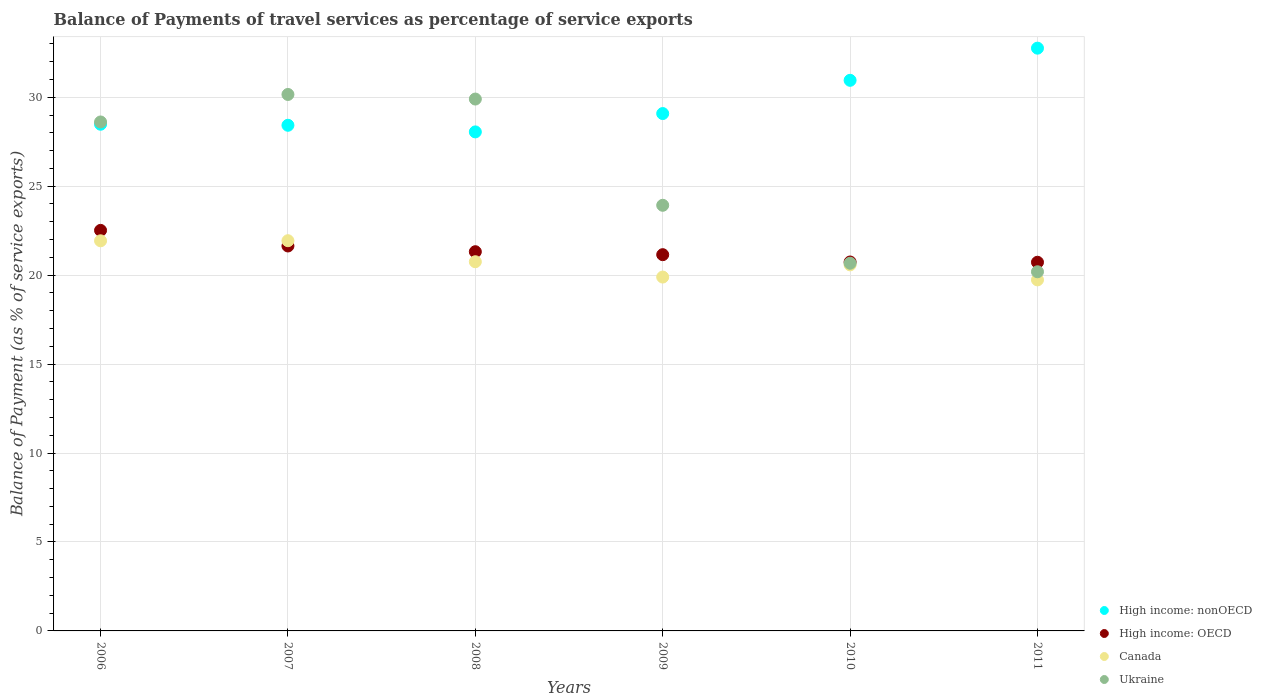How many different coloured dotlines are there?
Offer a very short reply. 4. Is the number of dotlines equal to the number of legend labels?
Provide a succinct answer. Yes. What is the balance of payments of travel services in High income: OECD in 2008?
Your response must be concise. 21.32. Across all years, what is the maximum balance of payments of travel services in Canada?
Provide a short and direct response. 21.94. Across all years, what is the minimum balance of payments of travel services in High income: nonOECD?
Your response must be concise. 28.05. In which year was the balance of payments of travel services in Ukraine maximum?
Ensure brevity in your answer.  2007. In which year was the balance of payments of travel services in Canada minimum?
Ensure brevity in your answer.  2011. What is the total balance of payments of travel services in Canada in the graph?
Offer a very short reply. 124.82. What is the difference between the balance of payments of travel services in Ukraine in 2008 and that in 2009?
Give a very brief answer. 5.97. What is the difference between the balance of payments of travel services in Ukraine in 2006 and the balance of payments of travel services in Canada in 2010?
Give a very brief answer. 8.03. What is the average balance of payments of travel services in Canada per year?
Ensure brevity in your answer.  20.8. In the year 2006, what is the difference between the balance of payments of travel services in Ukraine and balance of payments of travel services in Canada?
Your response must be concise. 6.68. What is the ratio of the balance of payments of travel services in High income: nonOECD in 2010 to that in 2011?
Provide a succinct answer. 0.94. Is the difference between the balance of payments of travel services in Ukraine in 2007 and 2009 greater than the difference between the balance of payments of travel services in Canada in 2007 and 2009?
Ensure brevity in your answer.  Yes. What is the difference between the highest and the second highest balance of payments of travel services in High income: nonOECD?
Your response must be concise. 1.81. What is the difference between the highest and the lowest balance of payments of travel services in High income: nonOECD?
Provide a succinct answer. 4.71. In how many years, is the balance of payments of travel services in High income: nonOECD greater than the average balance of payments of travel services in High income: nonOECD taken over all years?
Offer a terse response. 2. Is the sum of the balance of payments of travel services in High income: nonOECD in 2006 and 2010 greater than the maximum balance of payments of travel services in Canada across all years?
Your response must be concise. Yes. Is it the case that in every year, the sum of the balance of payments of travel services in Canada and balance of payments of travel services in Ukraine  is greater than the sum of balance of payments of travel services in High income: nonOECD and balance of payments of travel services in High income: OECD?
Provide a short and direct response. No. Is it the case that in every year, the sum of the balance of payments of travel services in High income: OECD and balance of payments of travel services in High income: nonOECD  is greater than the balance of payments of travel services in Canada?
Provide a succinct answer. Yes. Does the balance of payments of travel services in High income: nonOECD monotonically increase over the years?
Keep it short and to the point. No. Is the balance of payments of travel services in High income: OECD strictly greater than the balance of payments of travel services in Canada over the years?
Provide a short and direct response. No. What is the difference between two consecutive major ticks on the Y-axis?
Offer a terse response. 5. Are the values on the major ticks of Y-axis written in scientific E-notation?
Your response must be concise. No. Does the graph contain any zero values?
Keep it short and to the point. No. Does the graph contain grids?
Provide a succinct answer. Yes. How many legend labels are there?
Offer a very short reply. 4. How are the legend labels stacked?
Give a very brief answer. Vertical. What is the title of the graph?
Provide a succinct answer. Balance of Payments of travel services as percentage of service exports. What is the label or title of the Y-axis?
Your answer should be very brief. Balance of Payment (as % of service exports). What is the Balance of Payment (as % of service exports) of High income: nonOECD in 2006?
Your response must be concise. 28.48. What is the Balance of Payment (as % of service exports) in High income: OECD in 2006?
Ensure brevity in your answer.  22.52. What is the Balance of Payment (as % of service exports) in Canada in 2006?
Your response must be concise. 21.93. What is the Balance of Payment (as % of service exports) of Ukraine in 2006?
Ensure brevity in your answer.  28.61. What is the Balance of Payment (as % of service exports) in High income: nonOECD in 2007?
Ensure brevity in your answer.  28.42. What is the Balance of Payment (as % of service exports) in High income: OECD in 2007?
Offer a terse response. 21.64. What is the Balance of Payment (as % of service exports) of Canada in 2007?
Make the answer very short. 21.94. What is the Balance of Payment (as % of service exports) of Ukraine in 2007?
Keep it short and to the point. 30.16. What is the Balance of Payment (as % of service exports) in High income: nonOECD in 2008?
Give a very brief answer. 28.05. What is the Balance of Payment (as % of service exports) of High income: OECD in 2008?
Offer a terse response. 21.32. What is the Balance of Payment (as % of service exports) in Canada in 2008?
Make the answer very short. 20.75. What is the Balance of Payment (as % of service exports) of Ukraine in 2008?
Your response must be concise. 29.9. What is the Balance of Payment (as % of service exports) in High income: nonOECD in 2009?
Your answer should be very brief. 29.08. What is the Balance of Payment (as % of service exports) in High income: OECD in 2009?
Offer a terse response. 21.15. What is the Balance of Payment (as % of service exports) in Canada in 2009?
Provide a short and direct response. 19.89. What is the Balance of Payment (as % of service exports) in Ukraine in 2009?
Your answer should be compact. 23.93. What is the Balance of Payment (as % of service exports) in High income: nonOECD in 2010?
Provide a succinct answer. 30.95. What is the Balance of Payment (as % of service exports) in High income: OECD in 2010?
Offer a terse response. 20.74. What is the Balance of Payment (as % of service exports) in Canada in 2010?
Your answer should be compact. 20.58. What is the Balance of Payment (as % of service exports) of Ukraine in 2010?
Give a very brief answer. 20.67. What is the Balance of Payment (as % of service exports) of High income: nonOECD in 2011?
Your response must be concise. 32.76. What is the Balance of Payment (as % of service exports) in High income: OECD in 2011?
Ensure brevity in your answer.  20.72. What is the Balance of Payment (as % of service exports) in Canada in 2011?
Keep it short and to the point. 19.73. What is the Balance of Payment (as % of service exports) in Ukraine in 2011?
Offer a very short reply. 20.19. Across all years, what is the maximum Balance of Payment (as % of service exports) in High income: nonOECD?
Keep it short and to the point. 32.76. Across all years, what is the maximum Balance of Payment (as % of service exports) of High income: OECD?
Your answer should be very brief. 22.52. Across all years, what is the maximum Balance of Payment (as % of service exports) of Canada?
Provide a succinct answer. 21.94. Across all years, what is the maximum Balance of Payment (as % of service exports) of Ukraine?
Provide a short and direct response. 30.16. Across all years, what is the minimum Balance of Payment (as % of service exports) of High income: nonOECD?
Your response must be concise. 28.05. Across all years, what is the minimum Balance of Payment (as % of service exports) of High income: OECD?
Your answer should be very brief. 20.72. Across all years, what is the minimum Balance of Payment (as % of service exports) in Canada?
Offer a terse response. 19.73. Across all years, what is the minimum Balance of Payment (as % of service exports) of Ukraine?
Your response must be concise. 20.19. What is the total Balance of Payment (as % of service exports) of High income: nonOECD in the graph?
Provide a short and direct response. 177.75. What is the total Balance of Payment (as % of service exports) of High income: OECD in the graph?
Your response must be concise. 128.09. What is the total Balance of Payment (as % of service exports) in Canada in the graph?
Offer a terse response. 124.82. What is the total Balance of Payment (as % of service exports) of Ukraine in the graph?
Your response must be concise. 153.45. What is the difference between the Balance of Payment (as % of service exports) in High income: nonOECD in 2006 and that in 2007?
Offer a very short reply. 0.06. What is the difference between the Balance of Payment (as % of service exports) of High income: OECD in 2006 and that in 2007?
Provide a succinct answer. 0.88. What is the difference between the Balance of Payment (as % of service exports) in Canada in 2006 and that in 2007?
Provide a succinct answer. -0.01. What is the difference between the Balance of Payment (as % of service exports) in Ukraine in 2006 and that in 2007?
Give a very brief answer. -1.55. What is the difference between the Balance of Payment (as % of service exports) of High income: nonOECD in 2006 and that in 2008?
Provide a short and direct response. 0.43. What is the difference between the Balance of Payment (as % of service exports) of High income: OECD in 2006 and that in 2008?
Your answer should be very brief. 1.2. What is the difference between the Balance of Payment (as % of service exports) in Canada in 2006 and that in 2008?
Give a very brief answer. 1.18. What is the difference between the Balance of Payment (as % of service exports) in Ukraine in 2006 and that in 2008?
Offer a very short reply. -1.29. What is the difference between the Balance of Payment (as % of service exports) of High income: nonOECD in 2006 and that in 2009?
Your response must be concise. -0.6. What is the difference between the Balance of Payment (as % of service exports) in High income: OECD in 2006 and that in 2009?
Keep it short and to the point. 1.37. What is the difference between the Balance of Payment (as % of service exports) in Canada in 2006 and that in 2009?
Your answer should be very brief. 2.04. What is the difference between the Balance of Payment (as % of service exports) of Ukraine in 2006 and that in 2009?
Your answer should be very brief. 4.68. What is the difference between the Balance of Payment (as % of service exports) in High income: nonOECD in 2006 and that in 2010?
Your answer should be very brief. -2.47. What is the difference between the Balance of Payment (as % of service exports) of High income: OECD in 2006 and that in 2010?
Offer a terse response. 1.78. What is the difference between the Balance of Payment (as % of service exports) of Canada in 2006 and that in 2010?
Ensure brevity in your answer.  1.35. What is the difference between the Balance of Payment (as % of service exports) in Ukraine in 2006 and that in 2010?
Your answer should be compact. 7.94. What is the difference between the Balance of Payment (as % of service exports) of High income: nonOECD in 2006 and that in 2011?
Your answer should be compact. -4.28. What is the difference between the Balance of Payment (as % of service exports) of High income: OECD in 2006 and that in 2011?
Keep it short and to the point. 1.79. What is the difference between the Balance of Payment (as % of service exports) in Canada in 2006 and that in 2011?
Keep it short and to the point. 2.2. What is the difference between the Balance of Payment (as % of service exports) of Ukraine in 2006 and that in 2011?
Offer a very short reply. 8.42. What is the difference between the Balance of Payment (as % of service exports) of High income: nonOECD in 2007 and that in 2008?
Provide a short and direct response. 0.37. What is the difference between the Balance of Payment (as % of service exports) of High income: OECD in 2007 and that in 2008?
Your response must be concise. 0.32. What is the difference between the Balance of Payment (as % of service exports) of Canada in 2007 and that in 2008?
Offer a very short reply. 1.18. What is the difference between the Balance of Payment (as % of service exports) in Ukraine in 2007 and that in 2008?
Your answer should be very brief. 0.26. What is the difference between the Balance of Payment (as % of service exports) of High income: nonOECD in 2007 and that in 2009?
Your answer should be very brief. -0.66. What is the difference between the Balance of Payment (as % of service exports) of High income: OECD in 2007 and that in 2009?
Keep it short and to the point. 0.49. What is the difference between the Balance of Payment (as % of service exports) in Canada in 2007 and that in 2009?
Make the answer very short. 2.04. What is the difference between the Balance of Payment (as % of service exports) in Ukraine in 2007 and that in 2009?
Your response must be concise. 6.23. What is the difference between the Balance of Payment (as % of service exports) in High income: nonOECD in 2007 and that in 2010?
Keep it short and to the point. -2.53. What is the difference between the Balance of Payment (as % of service exports) in High income: OECD in 2007 and that in 2010?
Your answer should be compact. 0.9. What is the difference between the Balance of Payment (as % of service exports) in Canada in 2007 and that in 2010?
Make the answer very short. 1.36. What is the difference between the Balance of Payment (as % of service exports) in Ukraine in 2007 and that in 2010?
Offer a very short reply. 9.49. What is the difference between the Balance of Payment (as % of service exports) of High income: nonOECD in 2007 and that in 2011?
Provide a succinct answer. -4.33. What is the difference between the Balance of Payment (as % of service exports) in High income: OECD in 2007 and that in 2011?
Ensure brevity in your answer.  0.91. What is the difference between the Balance of Payment (as % of service exports) in Canada in 2007 and that in 2011?
Give a very brief answer. 2.2. What is the difference between the Balance of Payment (as % of service exports) of Ukraine in 2007 and that in 2011?
Keep it short and to the point. 9.97. What is the difference between the Balance of Payment (as % of service exports) of High income: nonOECD in 2008 and that in 2009?
Your answer should be very brief. -1.03. What is the difference between the Balance of Payment (as % of service exports) of High income: OECD in 2008 and that in 2009?
Provide a short and direct response. 0.17. What is the difference between the Balance of Payment (as % of service exports) of Canada in 2008 and that in 2009?
Your answer should be compact. 0.86. What is the difference between the Balance of Payment (as % of service exports) in Ukraine in 2008 and that in 2009?
Your answer should be very brief. 5.97. What is the difference between the Balance of Payment (as % of service exports) in High income: nonOECD in 2008 and that in 2010?
Make the answer very short. -2.9. What is the difference between the Balance of Payment (as % of service exports) of High income: OECD in 2008 and that in 2010?
Offer a very short reply. 0.58. What is the difference between the Balance of Payment (as % of service exports) of Canada in 2008 and that in 2010?
Your response must be concise. 0.18. What is the difference between the Balance of Payment (as % of service exports) of Ukraine in 2008 and that in 2010?
Your answer should be very brief. 9.23. What is the difference between the Balance of Payment (as % of service exports) of High income: nonOECD in 2008 and that in 2011?
Your answer should be compact. -4.71. What is the difference between the Balance of Payment (as % of service exports) in High income: OECD in 2008 and that in 2011?
Provide a succinct answer. 0.59. What is the difference between the Balance of Payment (as % of service exports) of Canada in 2008 and that in 2011?
Your response must be concise. 1.02. What is the difference between the Balance of Payment (as % of service exports) of Ukraine in 2008 and that in 2011?
Your answer should be very brief. 9.71. What is the difference between the Balance of Payment (as % of service exports) in High income: nonOECD in 2009 and that in 2010?
Provide a succinct answer. -1.87. What is the difference between the Balance of Payment (as % of service exports) in High income: OECD in 2009 and that in 2010?
Your answer should be very brief. 0.41. What is the difference between the Balance of Payment (as % of service exports) in Canada in 2009 and that in 2010?
Make the answer very short. -0.69. What is the difference between the Balance of Payment (as % of service exports) of Ukraine in 2009 and that in 2010?
Offer a terse response. 3.26. What is the difference between the Balance of Payment (as % of service exports) in High income: nonOECD in 2009 and that in 2011?
Make the answer very short. -3.68. What is the difference between the Balance of Payment (as % of service exports) in High income: OECD in 2009 and that in 2011?
Offer a terse response. 0.43. What is the difference between the Balance of Payment (as % of service exports) of Canada in 2009 and that in 2011?
Your response must be concise. 0.16. What is the difference between the Balance of Payment (as % of service exports) of Ukraine in 2009 and that in 2011?
Keep it short and to the point. 3.74. What is the difference between the Balance of Payment (as % of service exports) in High income: nonOECD in 2010 and that in 2011?
Keep it short and to the point. -1.81. What is the difference between the Balance of Payment (as % of service exports) in High income: OECD in 2010 and that in 2011?
Keep it short and to the point. 0.01. What is the difference between the Balance of Payment (as % of service exports) of Canada in 2010 and that in 2011?
Your answer should be very brief. 0.84. What is the difference between the Balance of Payment (as % of service exports) in Ukraine in 2010 and that in 2011?
Provide a succinct answer. 0.48. What is the difference between the Balance of Payment (as % of service exports) in High income: nonOECD in 2006 and the Balance of Payment (as % of service exports) in High income: OECD in 2007?
Keep it short and to the point. 6.84. What is the difference between the Balance of Payment (as % of service exports) in High income: nonOECD in 2006 and the Balance of Payment (as % of service exports) in Canada in 2007?
Offer a very short reply. 6.55. What is the difference between the Balance of Payment (as % of service exports) of High income: nonOECD in 2006 and the Balance of Payment (as % of service exports) of Ukraine in 2007?
Offer a terse response. -1.67. What is the difference between the Balance of Payment (as % of service exports) of High income: OECD in 2006 and the Balance of Payment (as % of service exports) of Canada in 2007?
Give a very brief answer. 0.58. What is the difference between the Balance of Payment (as % of service exports) in High income: OECD in 2006 and the Balance of Payment (as % of service exports) in Ukraine in 2007?
Your response must be concise. -7.64. What is the difference between the Balance of Payment (as % of service exports) in Canada in 2006 and the Balance of Payment (as % of service exports) in Ukraine in 2007?
Provide a succinct answer. -8.23. What is the difference between the Balance of Payment (as % of service exports) of High income: nonOECD in 2006 and the Balance of Payment (as % of service exports) of High income: OECD in 2008?
Keep it short and to the point. 7.17. What is the difference between the Balance of Payment (as % of service exports) of High income: nonOECD in 2006 and the Balance of Payment (as % of service exports) of Canada in 2008?
Your response must be concise. 7.73. What is the difference between the Balance of Payment (as % of service exports) in High income: nonOECD in 2006 and the Balance of Payment (as % of service exports) in Ukraine in 2008?
Give a very brief answer. -1.42. What is the difference between the Balance of Payment (as % of service exports) in High income: OECD in 2006 and the Balance of Payment (as % of service exports) in Canada in 2008?
Ensure brevity in your answer.  1.76. What is the difference between the Balance of Payment (as % of service exports) in High income: OECD in 2006 and the Balance of Payment (as % of service exports) in Ukraine in 2008?
Your answer should be compact. -7.38. What is the difference between the Balance of Payment (as % of service exports) of Canada in 2006 and the Balance of Payment (as % of service exports) of Ukraine in 2008?
Your response must be concise. -7.97. What is the difference between the Balance of Payment (as % of service exports) of High income: nonOECD in 2006 and the Balance of Payment (as % of service exports) of High income: OECD in 2009?
Your answer should be compact. 7.33. What is the difference between the Balance of Payment (as % of service exports) of High income: nonOECD in 2006 and the Balance of Payment (as % of service exports) of Canada in 2009?
Your answer should be very brief. 8.59. What is the difference between the Balance of Payment (as % of service exports) of High income: nonOECD in 2006 and the Balance of Payment (as % of service exports) of Ukraine in 2009?
Provide a short and direct response. 4.56. What is the difference between the Balance of Payment (as % of service exports) in High income: OECD in 2006 and the Balance of Payment (as % of service exports) in Canada in 2009?
Ensure brevity in your answer.  2.62. What is the difference between the Balance of Payment (as % of service exports) in High income: OECD in 2006 and the Balance of Payment (as % of service exports) in Ukraine in 2009?
Make the answer very short. -1.41. What is the difference between the Balance of Payment (as % of service exports) in Canada in 2006 and the Balance of Payment (as % of service exports) in Ukraine in 2009?
Offer a very short reply. -2. What is the difference between the Balance of Payment (as % of service exports) of High income: nonOECD in 2006 and the Balance of Payment (as % of service exports) of High income: OECD in 2010?
Ensure brevity in your answer.  7.74. What is the difference between the Balance of Payment (as % of service exports) of High income: nonOECD in 2006 and the Balance of Payment (as % of service exports) of Canada in 2010?
Offer a very short reply. 7.91. What is the difference between the Balance of Payment (as % of service exports) of High income: nonOECD in 2006 and the Balance of Payment (as % of service exports) of Ukraine in 2010?
Give a very brief answer. 7.81. What is the difference between the Balance of Payment (as % of service exports) in High income: OECD in 2006 and the Balance of Payment (as % of service exports) in Canada in 2010?
Ensure brevity in your answer.  1.94. What is the difference between the Balance of Payment (as % of service exports) in High income: OECD in 2006 and the Balance of Payment (as % of service exports) in Ukraine in 2010?
Provide a succinct answer. 1.85. What is the difference between the Balance of Payment (as % of service exports) in Canada in 2006 and the Balance of Payment (as % of service exports) in Ukraine in 2010?
Provide a short and direct response. 1.26. What is the difference between the Balance of Payment (as % of service exports) of High income: nonOECD in 2006 and the Balance of Payment (as % of service exports) of High income: OECD in 2011?
Make the answer very short. 7.76. What is the difference between the Balance of Payment (as % of service exports) of High income: nonOECD in 2006 and the Balance of Payment (as % of service exports) of Canada in 2011?
Provide a succinct answer. 8.75. What is the difference between the Balance of Payment (as % of service exports) of High income: nonOECD in 2006 and the Balance of Payment (as % of service exports) of Ukraine in 2011?
Ensure brevity in your answer.  8.29. What is the difference between the Balance of Payment (as % of service exports) in High income: OECD in 2006 and the Balance of Payment (as % of service exports) in Canada in 2011?
Provide a succinct answer. 2.78. What is the difference between the Balance of Payment (as % of service exports) of High income: OECD in 2006 and the Balance of Payment (as % of service exports) of Ukraine in 2011?
Provide a succinct answer. 2.33. What is the difference between the Balance of Payment (as % of service exports) in Canada in 2006 and the Balance of Payment (as % of service exports) in Ukraine in 2011?
Offer a terse response. 1.74. What is the difference between the Balance of Payment (as % of service exports) in High income: nonOECD in 2007 and the Balance of Payment (as % of service exports) in High income: OECD in 2008?
Keep it short and to the point. 7.11. What is the difference between the Balance of Payment (as % of service exports) of High income: nonOECD in 2007 and the Balance of Payment (as % of service exports) of Canada in 2008?
Provide a succinct answer. 7.67. What is the difference between the Balance of Payment (as % of service exports) of High income: nonOECD in 2007 and the Balance of Payment (as % of service exports) of Ukraine in 2008?
Offer a very short reply. -1.47. What is the difference between the Balance of Payment (as % of service exports) of High income: OECD in 2007 and the Balance of Payment (as % of service exports) of Canada in 2008?
Your response must be concise. 0.89. What is the difference between the Balance of Payment (as % of service exports) in High income: OECD in 2007 and the Balance of Payment (as % of service exports) in Ukraine in 2008?
Provide a succinct answer. -8.26. What is the difference between the Balance of Payment (as % of service exports) of Canada in 2007 and the Balance of Payment (as % of service exports) of Ukraine in 2008?
Keep it short and to the point. -7.96. What is the difference between the Balance of Payment (as % of service exports) of High income: nonOECD in 2007 and the Balance of Payment (as % of service exports) of High income: OECD in 2009?
Make the answer very short. 7.27. What is the difference between the Balance of Payment (as % of service exports) of High income: nonOECD in 2007 and the Balance of Payment (as % of service exports) of Canada in 2009?
Ensure brevity in your answer.  8.53. What is the difference between the Balance of Payment (as % of service exports) of High income: nonOECD in 2007 and the Balance of Payment (as % of service exports) of Ukraine in 2009?
Your response must be concise. 4.5. What is the difference between the Balance of Payment (as % of service exports) in High income: OECD in 2007 and the Balance of Payment (as % of service exports) in Canada in 2009?
Your answer should be compact. 1.75. What is the difference between the Balance of Payment (as % of service exports) of High income: OECD in 2007 and the Balance of Payment (as % of service exports) of Ukraine in 2009?
Your answer should be very brief. -2.29. What is the difference between the Balance of Payment (as % of service exports) of Canada in 2007 and the Balance of Payment (as % of service exports) of Ukraine in 2009?
Offer a very short reply. -1.99. What is the difference between the Balance of Payment (as % of service exports) of High income: nonOECD in 2007 and the Balance of Payment (as % of service exports) of High income: OECD in 2010?
Ensure brevity in your answer.  7.69. What is the difference between the Balance of Payment (as % of service exports) of High income: nonOECD in 2007 and the Balance of Payment (as % of service exports) of Canada in 2010?
Your answer should be very brief. 7.85. What is the difference between the Balance of Payment (as % of service exports) in High income: nonOECD in 2007 and the Balance of Payment (as % of service exports) in Ukraine in 2010?
Offer a very short reply. 7.76. What is the difference between the Balance of Payment (as % of service exports) in High income: OECD in 2007 and the Balance of Payment (as % of service exports) in Canada in 2010?
Give a very brief answer. 1.06. What is the difference between the Balance of Payment (as % of service exports) in High income: OECD in 2007 and the Balance of Payment (as % of service exports) in Ukraine in 2010?
Offer a very short reply. 0.97. What is the difference between the Balance of Payment (as % of service exports) of Canada in 2007 and the Balance of Payment (as % of service exports) of Ukraine in 2010?
Your answer should be compact. 1.27. What is the difference between the Balance of Payment (as % of service exports) of High income: nonOECD in 2007 and the Balance of Payment (as % of service exports) of Canada in 2011?
Your answer should be compact. 8.69. What is the difference between the Balance of Payment (as % of service exports) of High income: nonOECD in 2007 and the Balance of Payment (as % of service exports) of Ukraine in 2011?
Your answer should be very brief. 8.24. What is the difference between the Balance of Payment (as % of service exports) of High income: OECD in 2007 and the Balance of Payment (as % of service exports) of Canada in 2011?
Make the answer very short. 1.91. What is the difference between the Balance of Payment (as % of service exports) in High income: OECD in 2007 and the Balance of Payment (as % of service exports) in Ukraine in 2011?
Provide a succinct answer. 1.45. What is the difference between the Balance of Payment (as % of service exports) of Canada in 2007 and the Balance of Payment (as % of service exports) of Ukraine in 2011?
Your answer should be very brief. 1.75. What is the difference between the Balance of Payment (as % of service exports) in High income: nonOECD in 2008 and the Balance of Payment (as % of service exports) in High income: OECD in 2009?
Your response must be concise. 6.9. What is the difference between the Balance of Payment (as % of service exports) in High income: nonOECD in 2008 and the Balance of Payment (as % of service exports) in Canada in 2009?
Your answer should be very brief. 8.16. What is the difference between the Balance of Payment (as % of service exports) in High income: nonOECD in 2008 and the Balance of Payment (as % of service exports) in Ukraine in 2009?
Offer a very short reply. 4.13. What is the difference between the Balance of Payment (as % of service exports) of High income: OECD in 2008 and the Balance of Payment (as % of service exports) of Canada in 2009?
Provide a succinct answer. 1.43. What is the difference between the Balance of Payment (as % of service exports) of High income: OECD in 2008 and the Balance of Payment (as % of service exports) of Ukraine in 2009?
Offer a terse response. -2.61. What is the difference between the Balance of Payment (as % of service exports) in Canada in 2008 and the Balance of Payment (as % of service exports) in Ukraine in 2009?
Provide a succinct answer. -3.17. What is the difference between the Balance of Payment (as % of service exports) in High income: nonOECD in 2008 and the Balance of Payment (as % of service exports) in High income: OECD in 2010?
Your answer should be compact. 7.31. What is the difference between the Balance of Payment (as % of service exports) in High income: nonOECD in 2008 and the Balance of Payment (as % of service exports) in Canada in 2010?
Your response must be concise. 7.47. What is the difference between the Balance of Payment (as % of service exports) in High income: nonOECD in 2008 and the Balance of Payment (as % of service exports) in Ukraine in 2010?
Offer a very short reply. 7.38. What is the difference between the Balance of Payment (as % of service exports) in High income: OECD in 2008 and the Balance of Payment (as % of service exports) in Canada in 2010?
Keep it short and to the point. 0.74. What is the difference between the Balance of Payment (as % of service exports) of High income: OECD in 2008 and the Balance of Payment (as % of service exports) of Ukraine in 2010?
Your answer should be very brief. 0.65. What is the difference between the Balance of Payment (as % of service exports) in Canada in 2008 and the Balance of Payment (as % of service exports) in Ukraine in 2010?
Ensure brevity in your answer.  0.08. What is the difference between the Balance of Payment (as % of service exports) of High income: nonOECD in 2008 and the Balance of Payment (as % of service exports) of High income: OECD in 2011?
Provide a short and direct response. 7.33. What is the difference between the Balance of Payment (as % of service exports) in High income: nonOECD in 2008 and the Balance of Payment (as % of service exports) in Canada in 2011?
Ensure brevity in your answer.  8.32. What is the difference between the Balance of Payment (as % of service exports) of High income: nonOECD in 2008 and the Balance of Payment (as % of service exports) of Ukraine in 2011?
Ensure brevity in your answer.  7.86. What is the difference between the Balance of Payment (as % of service exports) in High income: OECD in 2008 and the Balance of Payment (as % of service exports) in Canada in 2011?
Provide a succinct answer. 1.58. What is the difference between the Balance of Payment (as % of service exports) in High income: OECD in 2008 and the Balance of Payment (as % of service exports) in Ukraine in 2011?
Give a very brief answer. 1.13. What is the difference between the Balance of Payment (as % of service exports) of Canada in 2008 and the Balance of Payment (as % of service exports) of Ukraine in 2011?
Give a very brief answer. 0.56. What is the difference between the Balance of Payment (as % of service exports) of High income: nonOECD in 2009 and the Balance of Payment (as % of service exports) of High income: OECD in 2010?
Give a very brief answer. 8.34. What is the difference between the Balance of Payment (as % of service exports) in High income: nonOECD in 2009 and the Balance of Payment (as % of service exports) in Canada in 2010?
Give a very brief answer. 8.51. What is the difference between the Balance of Payment (as % of service exports) of High income: nonOECD in 2009 and the Balance of Payment (as % of service exports) of Ukraine in 2010?
Your answer should be compact. 8.41. What is the difference between the Balance of Payment (as % of service exports) of High income: OECD in 2009 and the Balance of Payment (as % of service exports) of Canada in 2010?
Provide a succinct answer. 0.57. What is the difference between the Balance of Payment (as % of service exports) of High income: OECD in 2009 and the Balance of Payment (as % of service exports) of Ukraine in 2010?
Keep it short and to the point. 0.48. What is the difference between the Balance of Payment (as % of service exports) in Canada in 2009 and the Balance of Payment (as % of service exports) in Ukraine in 2010?
Offer a terse response. -0.78. What is the difference between the Balance of Payment (as % of service exports) of High income: nonOECD in 2009 and the Balance of Payment (as % of service exports) of High income: OECD in 2011?
Provide a short and direct response. 8.36. What is the difference between the Balance of Payment (as % of service exports) in High income: nonOECD in 2009 and the Balance of Payment (as % of service exports) in Canada in 2011?
Give a very brief answer. 9.35. What is the difference between the Balance of Payment (as % of service exports) in High income: nonOECD in 2009 and the Balance of Payment (as % of service exports) in Ukraine in 2011?
Offer a very short reply. 8.89. What is the difference between the Balance of Payment (as % of service exports) of High income: OECD in 2009 and the Balance of Payment (as % of service exports) of Canada in 2011?
Provide a succinct answer. 1.42. What is the difference between the Balance of Payment (as % of service exports) in High income: OECD in 2009 and the Balance of Payment (as % of service exports) in Ukraine in 2011?
Your answer should be compact. 0.96. What is the difference between the Balance of Payment (as % of service exports) in Canada in 2009 and the Balance of Payment (as % of service exports) in Ukraine in 2011?
Ensure brevity in your answer.  -0.3. What is the difference between the Balance of Payment (as % of service exports) of High income: nonOECD in 2010 and the Balance of Payment (as % of service exports) of High income: OECD in 2011?
Offer a terse response. 10.23. What is the difference between the Balance of Payment (as % of service exports) in High income: nonOECD in 2010 and the Balance of Payment (as % of service exports) in Canada in 2011?
Your answer should be compact. 11.22. What is the difference between the Balance of Payment (as % of service exports) of High income: nonOECD in 2010 and the Balance of Payment (as % of service exports) of Ukraine in 2011?
Offer a terse response. 10.76. What is the difference between the Balance of Payment (as % of service exports) of High income: OECD in 2010 and the Balance of Payment (as % of service exports) of Canada in 2011?
Offer a terse response. 1.01. What is the difference between the Balance of Payment (as % of service exports) of High income: OECD in 2010 and the Balance of Payment (as % of service exports) of Ukraine in 2011?
Give a very brief answer. 0.55. What is the difference between the Balance of Payment (as % of service exports) of Canada in 2010 and the Balance of Payment (as % of service exports) of Ukraine in 2011?
Make the answer very short. 0.39. What is the average Balance of Payment (as % of service exports) in High income: nonOECD per year?
Give a very brief answer. 29.63. What is the average Balance of Payment (as % of service exports) in High income: OECD per year?
Your answer should be very brief. 21.35. What is the average Balance of Payment (as % of service exports) in Canada per year?
Give a very brief answer. 20.8. What is the average Balance of Payment (as % of service exports) in Ukraine per year?
Your response must be concise. 25.57. In the year 2006, what is the difference between the Balance of Payment (as % of service exports) in High income: nonOECD and Balance of Payment (as % of service exports) in High income: OECD?
Provide a short and direct response. 5.97. In the year 2006, what is the difference between the Balance of Payment (as % of service exports) in High income: nonOECD and Balance of Payment (as % of service exports) in Canada?
Offer a terse response. 6.55. In the year 2006, what is the difference between the Balance of Payment (as % of service exports) of High income: nonOECD and Balance of Payment (as % of service exports) of Ukraine?
Your response must be concise. -0.13. In the year 2006, what is the difference between the Balance of Payment (as % of service exports) in High income: OECD and Balance of Payment (as % of service exports) in Canada?
Provide a succinct answer. 0.59. In the year 2006, what is the difference between the Balance of Payment (as % of service exports) in High income: OECD and Balance of Payment (as % of service exports) in Ukraine?
Your answer should be very brief. -6.09. In the year 2006, what is the difference between the Balance of Payment (as % of service exports) in Canada and Balance of Payment (as % of service exports) in Ukraine?
Your response must be concise. -6.68. In the year 2007, what is the difference between the Balance of Payment (as % of service exports) in High income: nonOECD and Balance of Payment (as % of service exports) in High income: OECD?
Make the answer very short. 6.79. In the year 2007, what is the difference between the Balance of Payment (as % of service exports) in High income: nonOECD and Balance of Payment (as % of service exports) in Canada?
Your response must be concise. 6.49. In the year 2007, what is the difference between the Balance of Payment (as % of service exports) in High income: nonOECD and Balance of Payment (as % of service exports) in Ukraine?
Your answer should be compact. -1.73. In the year 2007, what is the difference between the Balance of Payment (as % of service exports) in High income: OECD and Balance of Payment (as % of service exports) in Canada?
Ensure brevity in your answer.  -0.3. In the year 2007, what is the difference between the Balance of Payment (as % of service exports) in High income: OECD and Balance of Payment (as % of service exports) in Ukraine?
Your answer should be very brief. -8.52. In the year 2007, what is the difference between the Balance of Payment (as % of service exports) in Canada and Balance of Payment (as % of service exports) in Ukraine?
Your answer should be compact. -8.22. In the year 2008, what is the difference between the Balance of Payment (as % of service exports) in High income: nonOECD and Balance of Payment (as % of service exports) in High income: OECD?
Your answer should be compact. 6.73. In the year 2008, what is the difference between the Balance of Payment (as % of service exports) in High income: nonOECD and Balance of Payment (as % of service exports) in Canada?
Offer a very short reply. 7.3. In the year 2008, what is the difference between the Balance of Payment (as % of service exports) in High income: nonOECD and Balance of Payment (as % of service exports) in Ukraine?
Give a very brief answer. -1.85. In the year 2008, what is the difference between the Balance of Payment (as % of service exports) of High income: OECD and Balance of Payment (as % of service exports) of Canada?
Your answer should be very brief. 0.56. In the year 2008, what is the difference between the Balance of Payment (as % of service exports) of High income: OECD and Balance of Payment (as % of service exports) of Ukraine?
Ensure brevity in your answer.  -8.58. In the year 2008, what is the difference between the Balance of Payment (as % of service exports) of Canada and Balance of Payment (as % of service exports) of Ukraine?
Provide a short and direct response. -9.14. In the year 2009, what is the difference between the Balance of Payment (as % of service exports) of High income: nonOECD and Balance of Payment (as % of service exports) of High income: OECD?
Your answer should be very brief. 7.93. In the year 2009, what is the difference between the Balance of Payment (as % of service exports) in High income: nonOECD and Balance of Payment (as % of service exports) in Canada?
Make the answer very short. 9.19. In the year 2009, what is the difference between the Balance of Payment (as % of service exports) in High income: nonOECD and Balance of Payment (as % of service exports) in Ukraine?
Your answer should be very brief. 5.16. In the year 2009, what is the difference between the Balance of Payment (as % of service exports) in High income: OECD and Balance of Payment (as % of service exports) in Canada?
Your response must be concise. 1.26. In the year 2009, what is the difference between the Balance of Payment (as % of service exports) of High income: OECD and Balance of Payment (as % of service exports) of Ukraine?
Keep it short and to the point. -2.78. In the year 2009, what is the difference between the Balance of Payment (as % of service exports) in Canada and Balance of Payment (as % of service exports) in Ukraine?
Your response must be concise. -4.03. In the year 2010, what is the difference between the Balance of Payment (as % of service exports) of High income: nonOECD and Balance of Payment (as % of service exports) of High income: OECD?
Ensure brevity in your answer.  10.21. In the year 2010, what is the difference between the Balance of Payment (as % of service exports) in High income: nonOECD and Balance of Payment (as % of service exports) in Canada?
Your response must be concise. 10.37. In the year 2010, what is the difference between the Balance of Payment (as % of service exports) in High income: nonOECD and Balance of Payment (as % of service exports) in Ukraine?
Your answer should be very brief. 10.28. In the year 2010, what is the difference between the Balance of Payment (as % of service exports) of High income: OECD and Balance of Payment (as % of service exports) of Canada?
Provide a short and direct response. 0.16. In the year 2010, what is the difference between the Balance of Payment (as % of service exports) of High income: OECD and Balance of Payment (as % of service exports) of Ukraine?
Your answer should be very brief. 0.07. In the year 2010, what is the difference between the Balance of Payment (as % of service exports) of Canada and Balance of Payment (as % of service exports) of Ukraine?
Your response must be concise. -0.09. In the year 2011, what is the difference between the Balance of Payment (as % of service exports) of High income: nonOECD and Balance of Payment (as % of service exports) of High income: OECD?
Offer a terse response. 12.03. In the year 2011, what is the difference between the Balance of Payment (as % of service exports) of High income: nonOECD and Balance of Payment (as % of service exports) of Canada?
Your answer should be very brief. 13.03. In the year 2011, what is the difference between the Balance of Payment (as % of service exports) in High income: nonOECD and Balance of Payment (as % of service exports) in Ukraine?
Give a very brief answer. 12.57. In the year 2011, what is the difference between the Balance of Payment (as % of service exports) in High income: OECD and Balance of Payment (as % of service exports) in Canada?
Your answer should be very brief. 0.99. In the year 2011, what is the difference between the Balance of Payment (as % of service exports) of High income: OECD and Balance of Payment (as % of service exports) of Ukraine?
Provide a succinct answer. 0.54. In the year 2011, what is the difference between the Balance of Payment (as % of service exports) of Canada and Balance of Payment (as % of service exports) of Ukraine?
Your answer should be compact. -0.46. What is the ratio of the Balance of Payment (as % of service exports) in High income: OECD in 2006 to that in 2007?
Keep it short and to the point. 1.04. What is the ratio of the Balance of Payment (as % of service exports) in Ukraine in 2006 to that in 2007?
Offer a very short reply. 0.95. What is the ratio of the Balance of Payment (as % of service exports) in High income: nonOECD in 2006 to that in 2008?
Offer a very short reply. 1.02. What is the ratio of the Balance of Payment (as % of service exports) in High income: OECD in 2006 to that in 2008?
Keep it short and to the point. 1.06. What is the ratio of the Balance of Payment (as % of service exports) in Canada in 2006 to that in 2008?
Offer a terse response. 1.06. What is the ratio of the Balance of Payment (as % of service exports) of Ukraine in 2006 to that in 2008?
Provide a succinct answer. 0.96. What is the ratio of the Balance of Payment (as % of service exports) in High income: nonOECD in 2006 to that in 2009?
Offer a very short reply. 0.98. What is the ratio of the Balance of Payment (as % of service exports) in High income: OECD in 2006 to that in 2009?
Keep it short and to the point. 1.06. What is the ratio of the Balance of Payment (as % of service exports) of Canada in 2006 to that in 2009?
Provide a short and direct response. 1.1. What is the ratio of the Balance of Payment (as % of service exports) in Ukraine in 2006 to that in 2009?
Your response must be concise. 1.2. What is the ratio of the Balance of Payment (as % of service exports) of High income: nonOECD in 2006 to that in 2010?
Keep it short and to the point. 0.92. What is the ratio of the Balance of Payment (as % of service exports) of High income: OECD in 2006 to that in 2010?
Make the answer very short. 1.09. What is the ratio of the Balance of Payment (as % of service exports) in Canada in 2006 to that in 2010?
Offer a terse response. 1.07. What is the ratio of the Balance of Payment (as % of service exports) of Ukraine in 2006 to that in 2010?
Offer a terse response. 1.38. What is the ratio of the Balance of Payment (as % of service exports) of High income: nonOECD in 2006 to that in 2011?
Provide a succinct answer. 0.87. What is the ratio of the Balance of Payment (as % of service exports) of High income: OECD in 2006 to that in 2011?
Provide a succinct answer. 1.09. What is the ratio of the Balance of Payment (as % of service exports) of Canada in 2006 to that in 2011?
Ensure brevity in your answer.  1.11. What is the ratio of the Balance of Payment (as % of service exports) in Ukraine in 2006 to that in 2011?
Make the answer very short. 1.42. What is the ratio of the Balance of Payment (as % of service exports) in High income: nonOECD in 2007 to that in 2008?
Ensure brevity in your answer.  1.01. What is the ratio of the Balance of Payment (as % of service exports) of High income: OECD in 2007 to that in 2008?
Make the answer very short. 1.02. What is the ratio of the Balance of Payment (as % of service exports) in Canada in 2007 to that in 2008?
Give a very brief answer. 1.06. What is the ratio of the Balance of Payment (as % of service exports) in Ukraine in 2007 to that in 2008?
Provide a succinct answer. 1.01. What is the ratio of the Balance of Payment (as % of service exports) in High income: nonOECD in 2007 to that in 2009?
Offer a very short reply. 0.98. What is the ratio of the Balance of Payment (as % of service exports) in High income: OECD in 2007 to that in 2009?
Your answer should be very brief. 1.02. What is the ratio of the Balance of Payment (as % of service exports) in Canada in 2007 to that in 2009?
Give a very brief answer. 1.1. What is the ratio of the Balance of Payment (as % of service exports) of Ukraine in 2007 to that in 2009?
Provide a short and direct response. 1.26. What is the ratio of the Balance of Payment (as % of service exports) in High income: nonOECD in 2007 to that in 2010?
Your response must be concise. 0.92. What is the ratio of the Balance of Payment (as % of service exports) in High income: OECD in 2007 to that in 2010?
Make the answer very short. 1.04. What is the ratio of the Balance of Payment (as % of service exports) in Canada in 2007 to that in 2010?
Your answer should be compact. 1.07. What is the ratio of the Balance of Payment (as % of service exports) of Ukraine in 2007 to that in 2010?
Offer a terse response. 1.46. What is the ratio of the Balance of Payment (as % of service exports) in High income: nonOECD in 2007 to that in 2011?
Ensure brevity in your answer.  0.87. What is the ratio of the Balance of Payment (as % of service exports) in High income: OECD in 2007 to that in 2011?
Provide a short and direct response. 1.04. What is the ratio of the Balance of Payment (as % of service exports) of Canada in 2007 to that in 2011?
Offer a terse response. 1.11. What is the ratio of the Balance of Payment (as % of service exports) of Ukraine in 2007 to that in 2011?
Ensure brevity in your answer.  1.49. What is the ratio of the Balance of Payment (as % of service exports) in High income: nonOECD in 2008 to that in 2009?
Ensure brevity in your answer.  0.96. What is the ratio of the Balance of Payment (as % of service exports) in High income: OECD in 2008 to that in 2009?
Offer a very short reply. 1.01. What is the ratio of the Balance of Payment (as % of service exports) of Canada in 2008 to that in 2009?
Provide a succinct answer. 1.04. What is the ratio of the Balance of Payment (as % of service exports) of Ukraine in 2008 to that in 2009?
Offer a terse response. 1.25. What is the ratio of the Balance of Payment (as % of service exports) in High income: nonOECD in 2008 to that in 2010?
Your answer should be compact. 0.91. What is the ratio of the Balance of Payment (as % of service exports) of High income: OECD in 2008 to that in 2010?
Your answer should be very brief. 1.03. What is the ratio of the Balance of Payment (as % of service exports) of Canada in 2008 to that in 2010?
Offer a very short reply. 1.01. What is the ratio of the Balance of Payment (as % of service exports) in Ukraine in 2008 to that in 2010?
Offer a terse response. 1.45. What is the ratio of the Balance of Payment (as % of service exports) in High income: nonOECD in 2008 to that in 2011?
Offer a very short reply. 0.86. What is the ratio of the Balance of Payment (as % of service exports) in High income: OECD in 2008 to that in 2011?
Your answer should be compact. 1.03. What is the ratio of the Balance of Payment (as % of service exports) in Canada in 2008 to that in 2011?
Your answer should be very brief. 1.05. What is the ratio of the Balance of Payment (as % of service exports) in Ukraine in 2008 to that in 2011?
Ensure brevity in your answer.  1.48. What is the ratio of the Balance of Payment (as % of service exports) of High income: nonOECD in 2009 to that in 2010?
Provide a succinct answer. 0.94. What is the ratio of the Balance of Payment (as % of service exports) in High income: OECD in 2009 to that in 2010?
Provide a short and direct response. 1.02. What is the ratio of the Balance of Payment (as % of service exports) of Canada in 2009 to that in 2010?
Offer a terse response. 0.97. What is the ratio of the Balance of Payment (as % of service exports) of Ukraine in 2009 to that in 2010?
Offer a terse response. 1.16. What is the ratio of the Balance of Payment (as % of service exports) in High income: nonOECD in 2009 to that in 2011?
Keep it short and to the point. 0.89. What is the ratio of the Balance of Payment (as % of service exports) in High income: OECD in 2009 to that in 2011?
Offer a very short reply. 1.02. What is the ratio of the Balance of Payment (as % of service exports) of Ukraine in 2009 to that in 2011?
Provide a short and direct response. 1.19. What is the ratio of the Balance of Payment (as % of service exports) of High income: nonOECD in 2010 to that in 2011?
Give a very brief answer. 0.94. What is the ratio of the Balance of Payment (as % of service exports) of Canada in 2010 to that in 2011?
Provide a short and direct response. 1.04. What is the ratio of the Balance of Payment (as % of service exports) in Ukraine in 2010 to that in 2011?
Your answer should be compact. 1.02. What is the difference between the highest and the second highest Balance of Payment (as % of service exports) of High income: nonOECD?
Provide a short and direct response. 1.81. What is the difference between the highest and the second highest Balance of Payment (as % of service exports) in High income: OECD?
Give a very brief answer. 0.88. What is the difference between the highest and the second highest Balance of Payment (as % of service exports) of Canada?
Keep it short and to the point. 0.01. What is the difference between the highest and the second highest Balance of Payment (as % of service exports) in Ukraine?
Make the answer very short. 0.26. What is the difference between the highest and the lowest Balance of Payment (as % of service exports) in High income: nonOECD?
Provide a succinct answer. 4.71. What is the difference between the highest and the lowest Balance of Payment (as % of service exports) in High income: OECD?
Ensure brevity in your answer.  1.79. What is the difference between the highest and the lowest Balance of Payment (as % of service exports) in Canada?
Offer a very short reply. 2.2. What is the difference between the highest and the lowest Balance of Payment (as % of service exports) in Ukraine?
Keep it short and to the point. 9.97. 